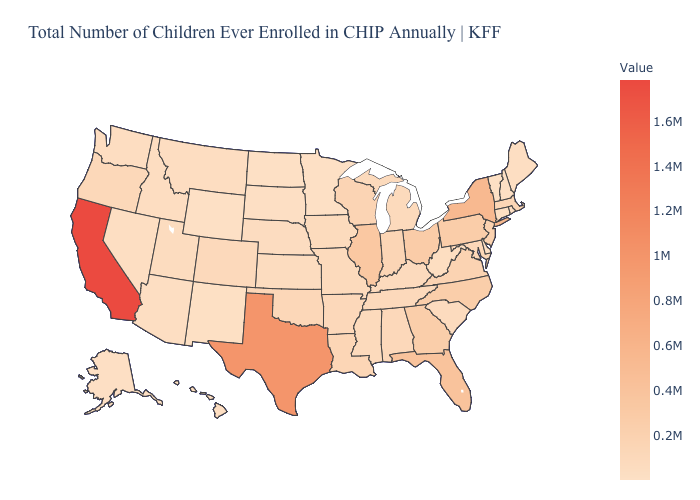Does Oklahoma have a higher value than California?
Concise answer only. No. Does Louisiana have a lower value than California?
Write a very short answer. Yes. Among the states that border Massachusetts , does New York have the highest value?
Be succinct. Yes. Among the states that border Connecticut , which have the lowest value?
Quick response, please. Rhode Island. Which states have the lowest value in the MidWest?
Short answer required. Minnesota. 